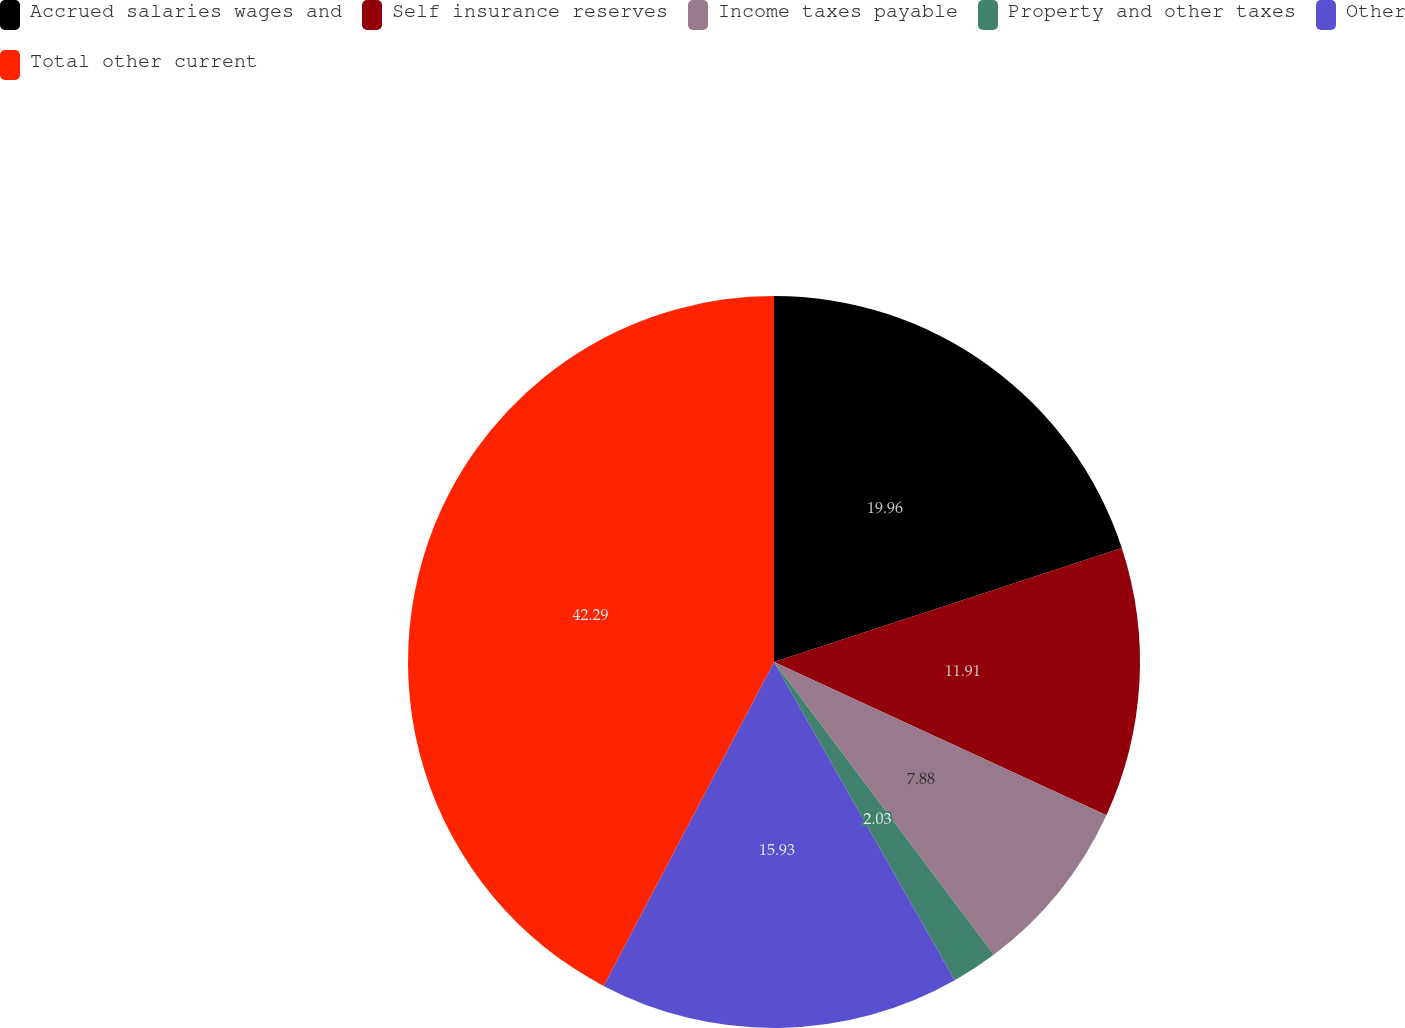Convert chart to OTSL. <chart><loc_0><loc_0><loc_500><loc_500><pie_chart><fcel>Accrued salaries wages and<fcel>Self insurance reserves<fcel>Income taxes payable<fcel>Property and other taxes<fcel>Other<fcel>Total other current<nl><fcel>19.96%<fcel>11.91%<fcel>7.88%<fcel>2.03%<fcel>15.93%<fcel>42.29%<nl></chart> 